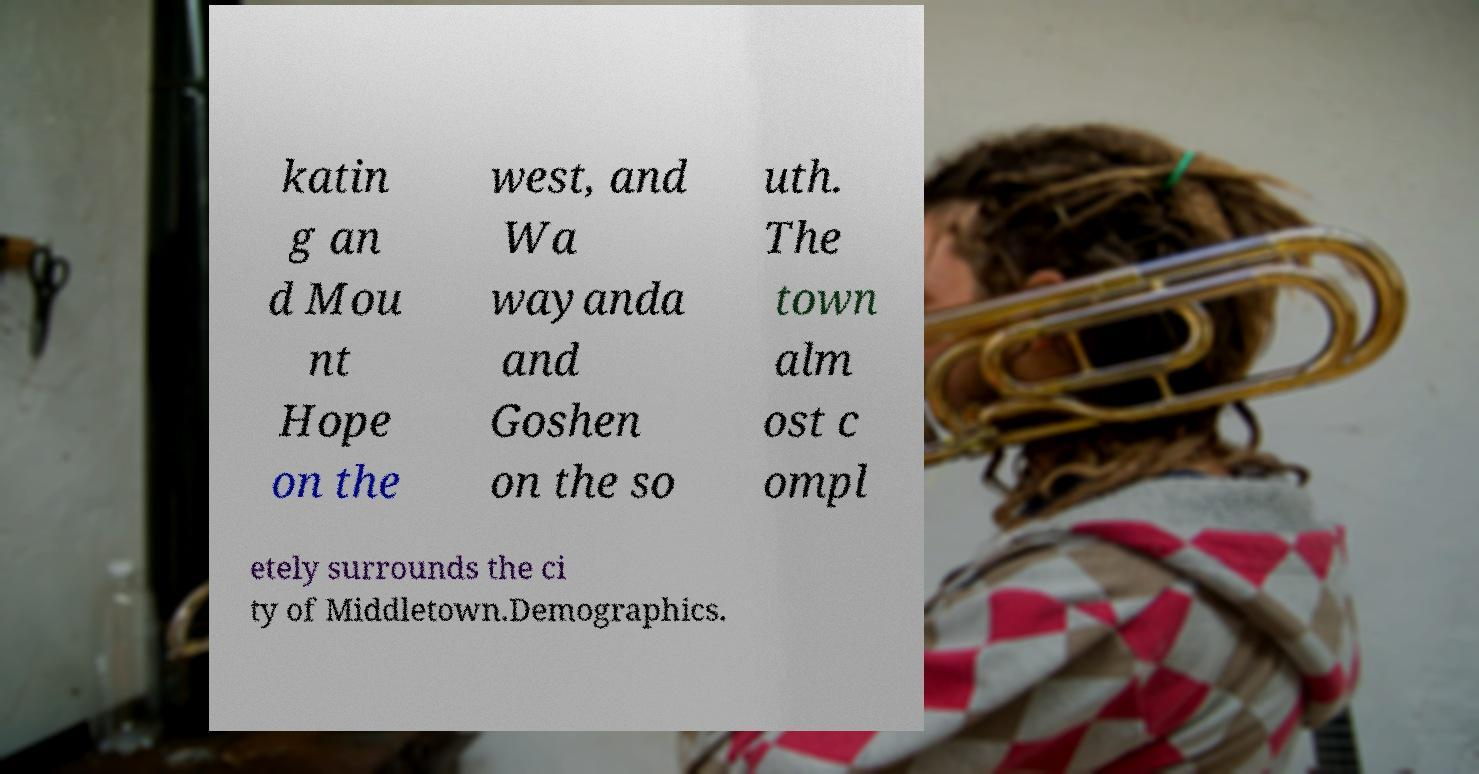Please identify and transcribe the text found in this image. katin g an d Mou nt Hope on the west, and Wa wayanda and Goshen on the so uth. The town alm ost c ompl etely surrounds the ci ty of Middletown.Demographics. 